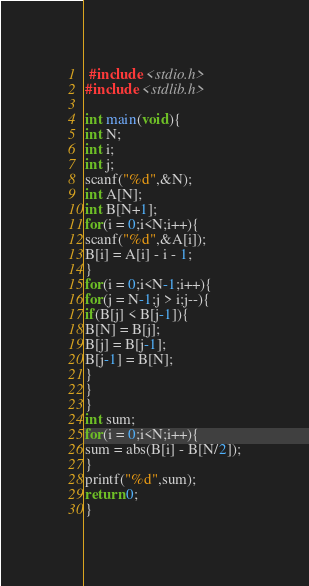Convert code to text. <code><loc_0><loc_0><loc_500><loc_500><_C++_> #include <stdio.h>
#include <stdlib.h>
             
int main(void){
int N;
int i;
int j;
scanf("%d",&N);
int A[N];
int B[N+1];
for(i = 0;i<N;i++){
scanf("%d",&A[i]);
B[i] = A[i] - i - 1;
}
for(i = 0;i<N-1;i++){
for(j = N-1;j > i;j--){
if(B[j] < B[j-1]){
B[N] = B[j];
B[j] = B[j-1];
B[j-1] = B[N];
}
}
}
int sum;
for(i = 0;i<N;i++){
sum = abs(B[i] - B[N/2]);
}
printf("%d",sum);
return 0;
}</code> 